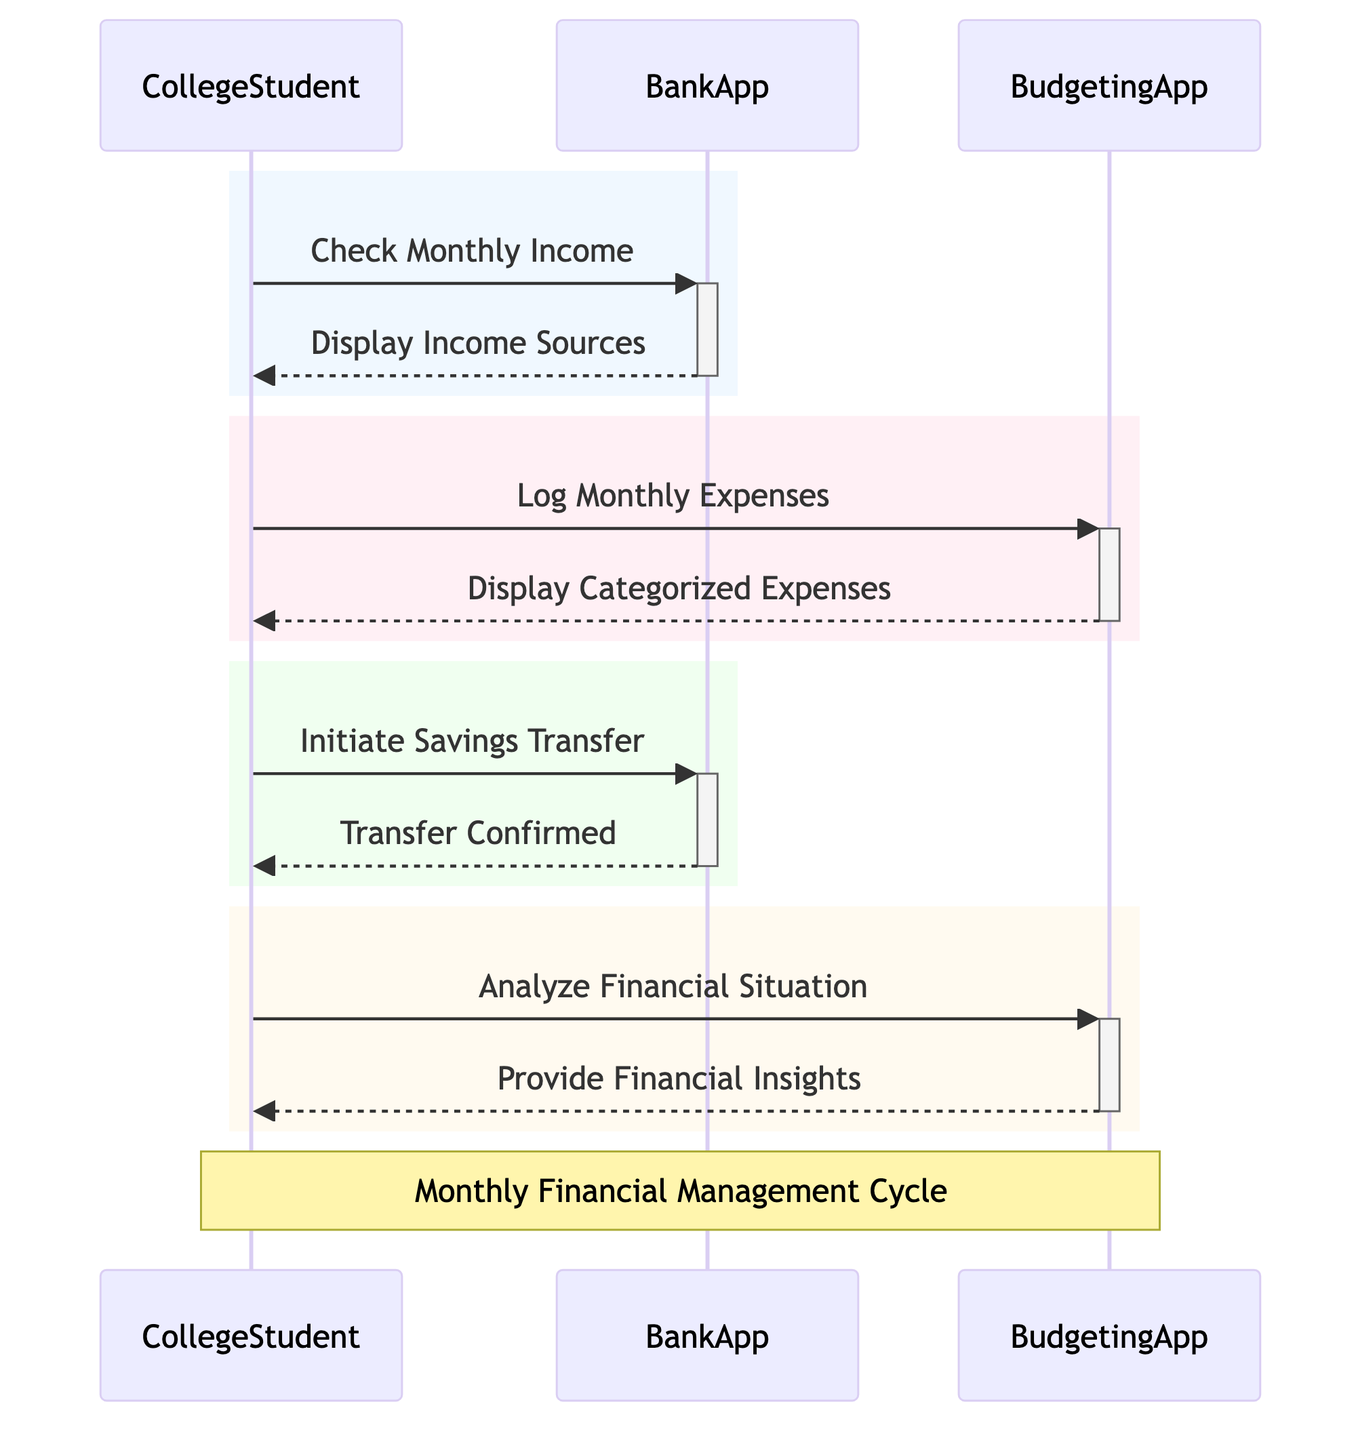What is the first action taken by the CollegeStudent? The first action in the sequence is the CollegeStudent checking their monthly income, which initiates the process.
Answer: Check Monthly Income How many actors are involved in the diagram? There are three actors listed: CollegeStudent, BankApp, and BudgetingApp.
Answer: 3 What does the BankApp display after the CollegeStudent checks their income? The BankApp responds to the CollegeStudent’s request by displaying the sources of income like part-time jobs, allowance, and scholarships.
Answer: Display Income Sources Which app is responsible for tracking expenses? The app designated for tracking expenses is the BudgetingApp, as it logs monthly expenses.
Answer: BudgetingApp What message follows after the CollegeStudent logs monthly expenses? After logging expenses, the BudgetingApp displays categorized expenses such as rent, groceries, and entertainment.
Answer: Display Categorized Expenses What is the action taken by the CollegeStudent to save money? The CollegeStudent initiates a savings transfer to put a certain amount into their savings account.
Answer: Initiate Savings Transfer How does the BankApp confirm the savings transfer? The BankApp confirms the action by providing a message indicating that the amount has been successfully moved to savings.
Answer: Transfer Confirmed Which task does the CollegeStudent perform after initiating the savings transfer? Following the savings transfer, the CollegeStudent analyzes their financial situation through the BudgetingApp.
Answer: Analyze Financial Situation What insights does the BudgetingApp provide after the financial analysis? The BudgetingApp offers financial insights such as recommendations to cut down on entertainment expenses and to increase savings.
Answer: Provide Financial Insights 